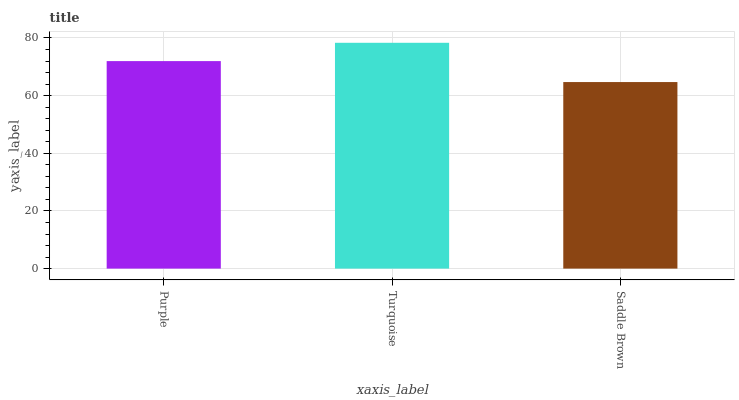Is Saddle Brown the minimum?
Answer yes or no. Yes. Is Turquoise the maximum?
Answer yes or no. Yes. Is Turquoise the minimum?
Answer yes or no. No. Is Saddle Brown the maximum?
Answer yes or no. No. Is Turquoise greater than Saddle Brown?
Answer yes or no. Yes. Is Saddle Brown less than Turquoise?
Answer yes or no. Yes. Is Saddle Brown greater than Turquoise?
Answer yes or no. No. Is Turquoise less than Saddle Brown?
Answer yes or no. No. Is Purple the high median?
Answer yes or no. Yes. Is Purple the low median?
Answer yes or no. Yes. Is Turquoise the high median?
Answer yes or no. No. Is Turquoise the low median?
Answer yes or no. No. 